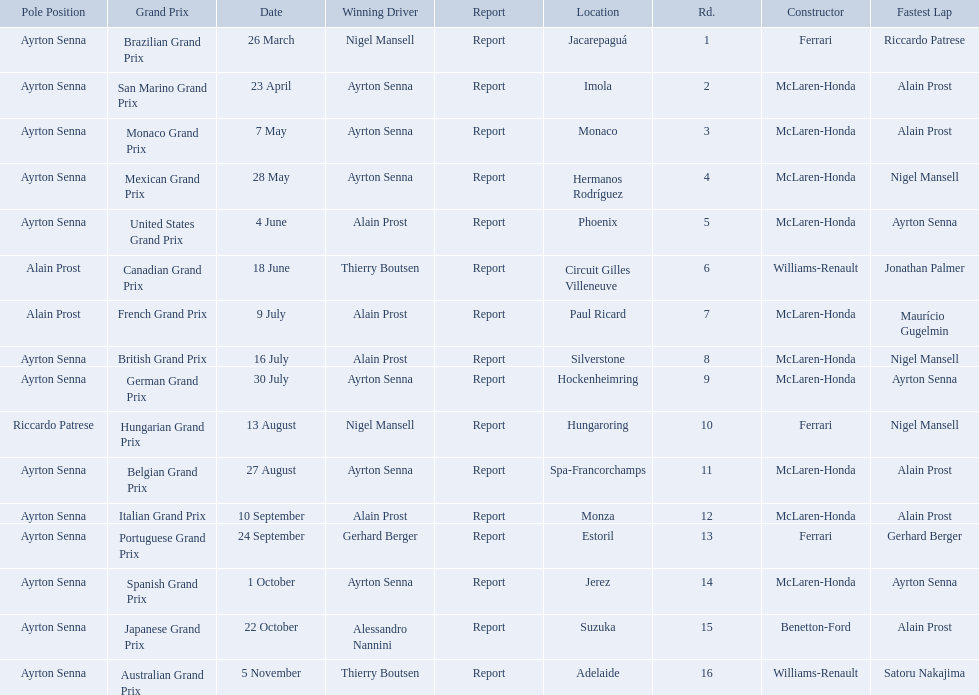Who are the constructors in the 1989 formula one season? Ferrari, McLaren-Honda, McLaren-Honda, McLaren-Honda, McLaren-Honda, Williams-Renault, McLaren-Honda, McLaren-Honda, McLaren-Honda, Ferrari, McLaren-Honda, McLaren-Honda, Ferrari, McLaren-Honda, Benetton-Ford, Williams-Renault. On what date was bennington ford the constructor? 22 October. What was the race on october 22? Japanese Grand Prix. Could you help me parse every detail presented in this table? {'header': ['Pole Position', 'Grand Prix', 'Date', 'Winning Driver', 'Report', 'Location', 'Rd.', 'Constructor', 'Fastest Lap'], 'rows': [['Ayrton Senna', 'Brazilian Grand Prix', '26 March', 'Nigel Mansell', 'Report', 'Jacarepaguá', '1', 'Ferrari', 'Riccardo Patrese'], ['Ayrton Senna', 'San Marino Grand Prix', '23 April', 'Ayrton Senna', 'Report', 'Imola', '2', 'McLaren-Honda', 'Alain Prost'], ['Ayrton Senna', 'Monaco Grand Prix', '7 May', 'Ayrton Senna', 'Report', 'Monaco', '3', 'McLaren-Honda', 'Alain Prost'], ['Ayrton Senna', 'Mexican Grand Prix', '28 May', 'Ayrton Senna', 'Report', 'Hermanos Rodríguez', '4', 'McLaren-Honda', 'Nigel Mansell'], ['Ayrton Senna', 'United States Grand Prix', '4 June', 'Alain Prost', 'Report', 'Phoenix', '5', 'McLaren-Honda', 'Ayrton Senna'], ['Alain Prost', 'Canadian Grand Prix', '18 June', 'Thierry Boutsen', 'Report', 'Circuit Gilles Villeneuve', '6', 'Williams-Renault', 'Jonathan Palmer'], ['Alain Prost', 'French Grand Prix', '9 July', 'Alain Prost', 'Report', 'Paul Ricard', '7', 'McLaren-Honda', 'Maurício Gugelmin'], ['Ayrton Senna', 'British Grand Prix', '16 July', 'Alain Prost', 'Report', 'Silverstone', '8', 'McLaren-Honda', 'Nigel Mansell'], ['Ayrton Senna', 'German Grand Prix', '30 July', 'Ayrton Senna', 'Report', 'Hockenheimring', '9', 'McLaren-Honda', 'Ayrton Senna'], ['Riccardo Patrese', 'Hungarian Grand Prix', '13 August', 'Nigel Mansell', 'Report', 'Hungaroring', '10', 'Ferrari', 'Nigel Mansell'], ['Ayrton Senna', 'Belgian Grand Prix', '27 August', 'Ayrton Senna', 'Report', 'Spa-Francorchamps', '11', 'McLaren-Honda', 'Alain Prost'], ['Ayrton Senna', 'Italian Grand Prix', '10 September', 'Alain Prost', 'Report', 'Monza', '12', 'McLaren-Honda', 'Alain Prost'], ['Ayrton Senna', 'Portuguese Grand Prix', '24 September', 'Gerhard Berger', 'Report', 'Estoril', '13', 'Ferrari', 'Gerhard Berger'], ['Ayrton Senna', 'Spanish Grand Prix', '1 October', 'Ayrton Senna', 'Report', 'Jerez', '14', 'McLaren-Honda', 'Ayrton Senna'], ['Ayrton Senna', 'Japanese Grand Prix', '22 October', 'Alessandro Nannini', 'Report', 'Suzuka', '15', 'Benetton-Ford', 'Alain Prost'], ['Ayrton Senna', 'Australian Grand Prix', '5 November', 'Thierry Boutsen', 'Report', 'Adelaide', '16', 'Williams-Renault', 'Satoru Nakajima']]} 